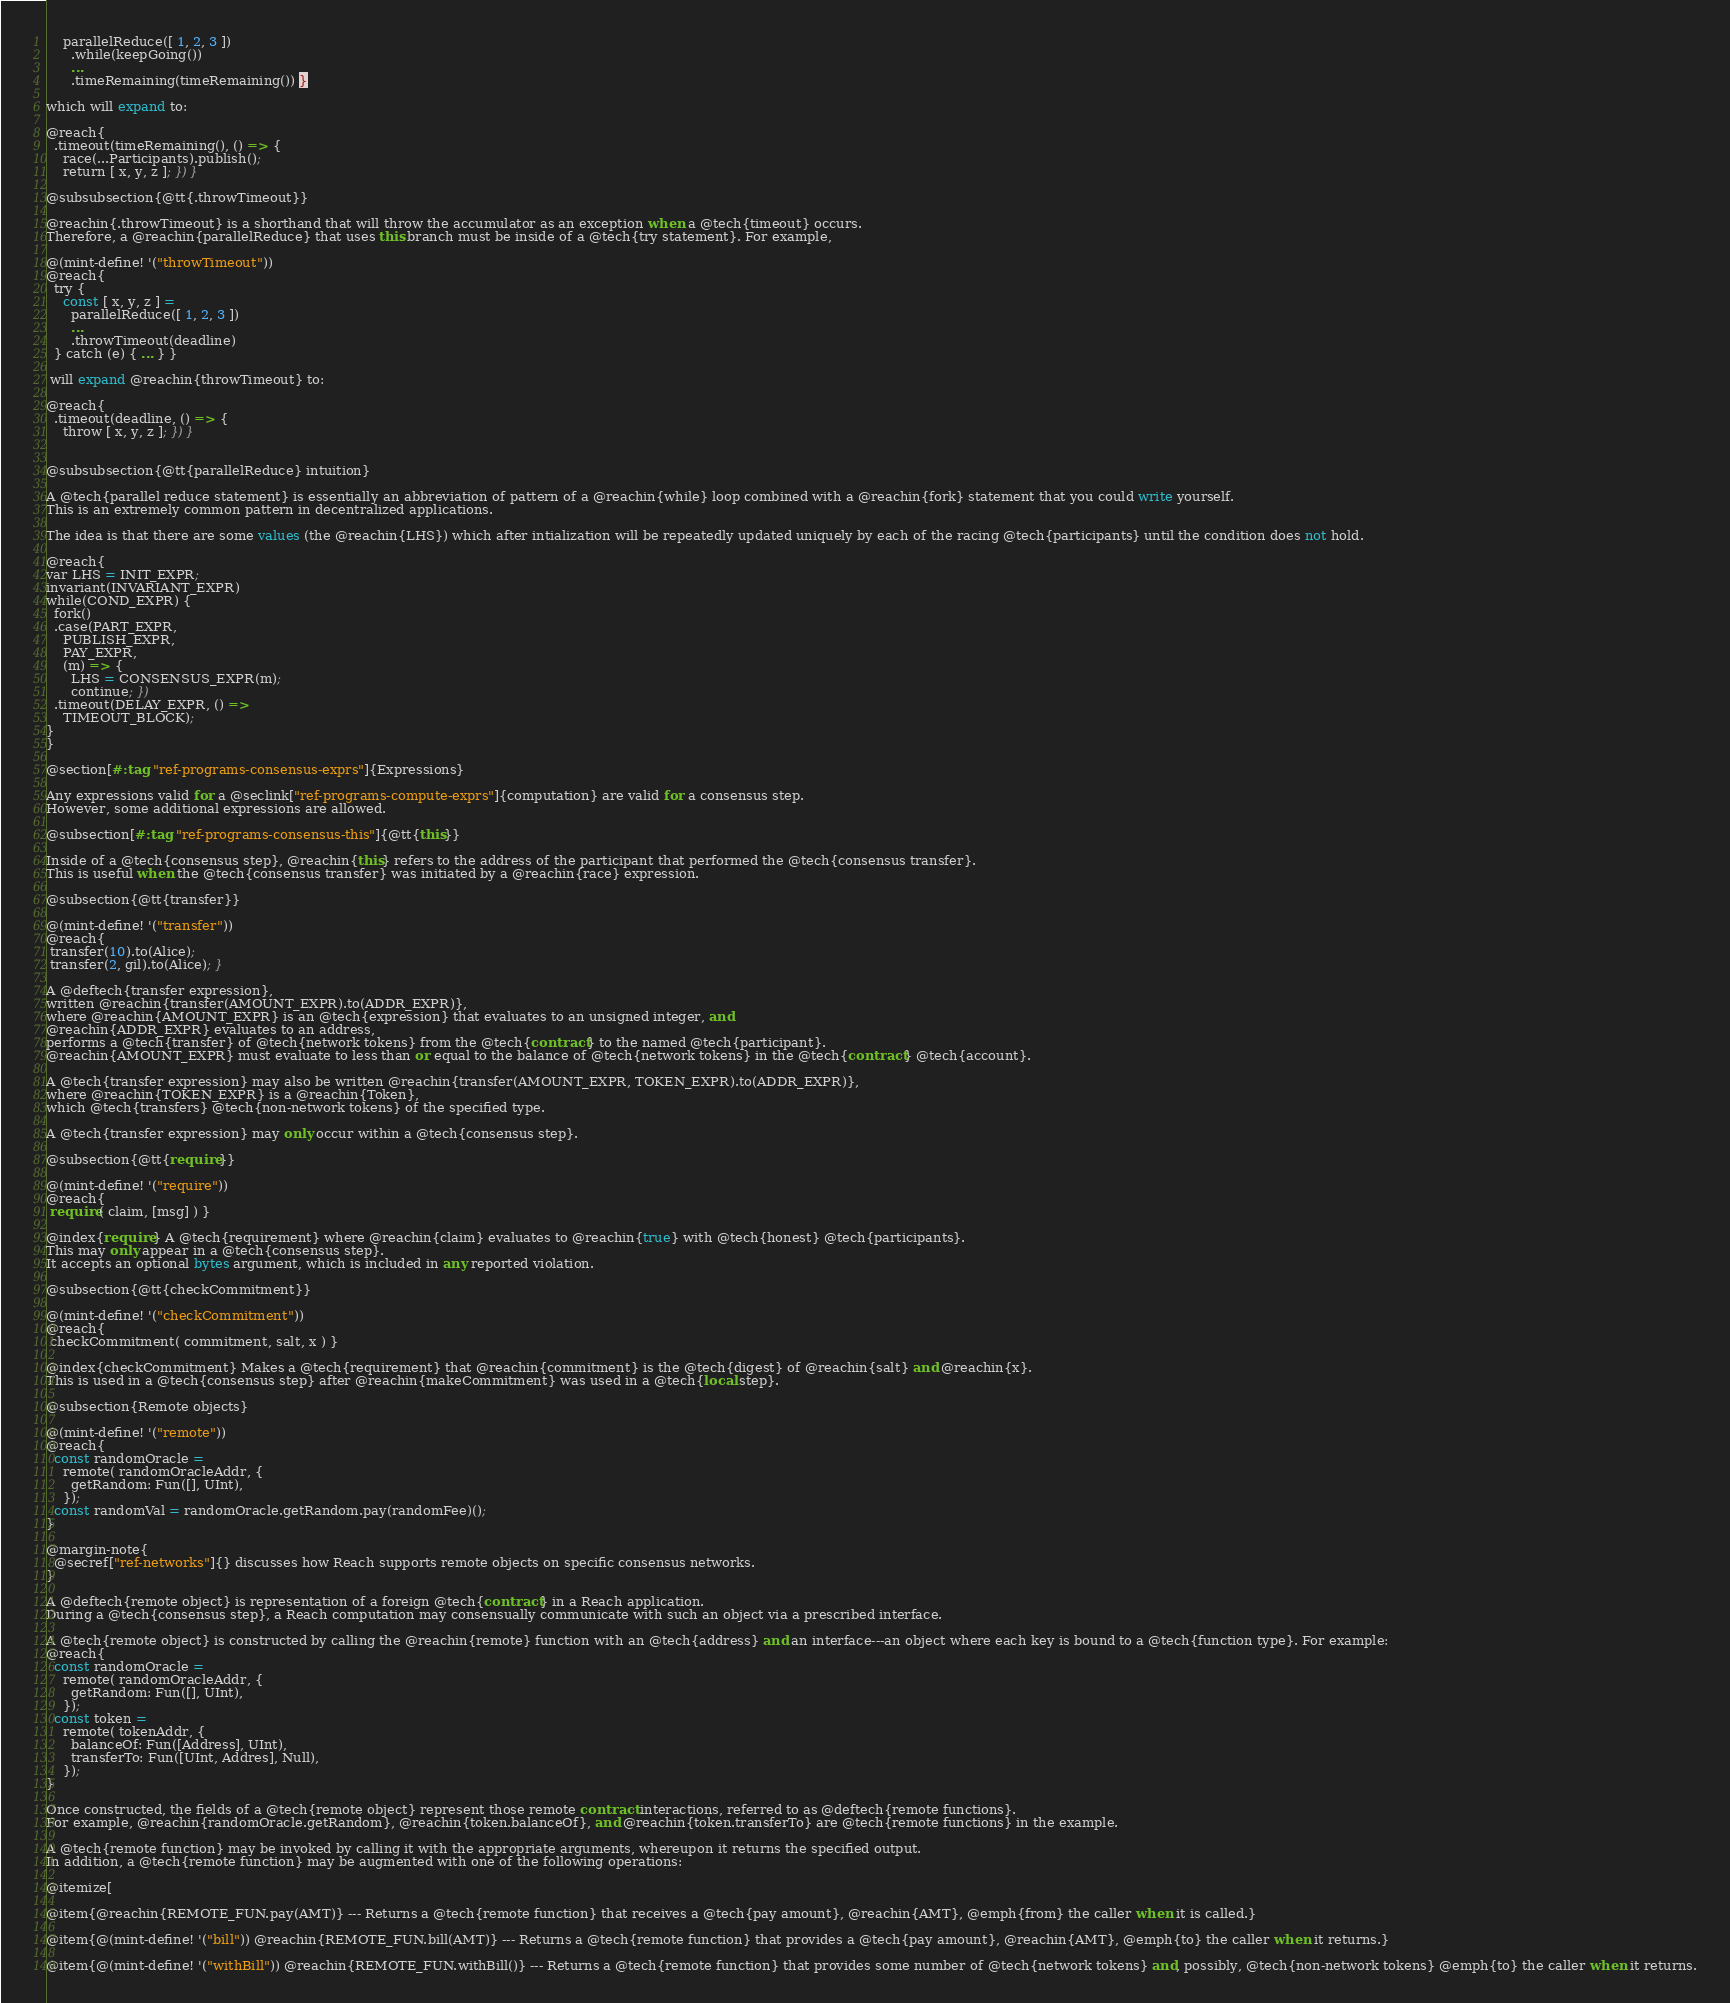<code> <loc_0><loc_0><loc_500><loc_500><_Racket_>    parallelReduce([ 1, 2, 3 ])
      .while(keepGoing())
      ...
      .timeRemaining(timeRemaining()) }

which will expand to:

@reach{
  .timeout(timeRemaining(), () => {
    race(...Participants).publish();
    return [ x, y, z ]; }) }

@subsubsection{@tt{.throwTimeout}}

@reachin{.throwTimeout} is a shorthand that will throw the accumulator as an exception when a @tech{timeout} occurs.
Therefore, a @reachin{parallelReduce} that uses this branch must be inside of a @tech{try statement}. For example,

@(mint-define! '("throwTimeout"))
@reach{
  try {
    const [ x, y, z ] =
      parallelReduce([ 1, 2, 3 ])
      ...
      .throwTimeout(deadline)
  } catch (e) { ... } }

 will expand @reachin{throwTimeout} to:

@reach{
  .timeout(deadline, () => {
    throw [ x, y, z ]; }) }


@subsubsection{@tt{parallelReduce} intuition}

A @tech{parallel reduce statement} is essentially an abbreviation of pattern of a @reachin{while} loop combined with a @reachin{fork} statement that you could write yourself.
This is an extremely common pattern in decentralized applications.

The idea is that there are some values (the @reachin{LHS}) which after intialization will be repeatedly updated uniquely by each of the racing @tech{participants} until the condition does not hold.

@reach{
var LHS = INIT_EXPR;
invariant(INVARIANT_EXPR)
while(COND_EXPR) {
  fork()
  .case(PART_EXPR,
    PUBLISH_EXPR,
    PAY_EXPR,
    (m) => {
      LHS = CONSENSUS_EXPR(m);
      continue; })
  .timeout(DELAY_EXPR, () =>
    TIMEOUT_BLOCK);
}
}

@section[#:tag "ref-programs-consensus-exprs"]{Expressions}

Any expressions valid for a @seclink["ref-programs-compute-exprs"]{computation} are valid for a consensus step.
However, some additional expressions are allowed.

@subsection[#:tag "ref-programs-consensus-this"]{@tt{this}}

Inside of a @tech{consensus step}, @reachin{this} refers to the address of the participant that performed the @tech{consensus transfer}.
This is useful when the @tech{consensus transfer} was initiated by a @reachin{race} expression.

@subsection{@tt{transfer}}

@(mint-define! '("transfer"))
@reach{
 transfer(10).to(Alice);
 transfer(2, gil).to(Alice); }

A @deftech{transfer expression},
written @reachin{transfer(AMOUNT_EXPR).to(ADDR_EXPR)},
where @reachin{AMOUNT_EXPR} is an @tech{expression} that evaluates to an unsigned integer, and
@reachin{ADDR_EXPR} evaluates to an address,
performs a @tech{transfer} of @tech{network tokens} from the @tech{contract} to the named @tech{participant}.
@reachin{AMOUNT_EXPR} must evaluate to less than or equal to the balance of @tech{network tokens} in the @tech{contract} @tech{account}.

A @tech{transfer expression} may also be written @reachin{transfer(AMOUNT_EXPR, TOKEN_EXPR).to(ADDR_EXPR)},
where @reachin{TOKEN_EXPR} is a @reachin{Token},
which @tech{transfers} @tech{non-network tokens} of the specified type.

A @tech{transfer expression} may only occur within a @tech{consensus step}.

@subsection{@tt{require}}

@(mint-define! '("require"))
@reach{
 require( claim, [msg] ) }

@index{require} A @tech{requirement} where @reachin{claim} evaluates to @reachin{true} with @tech{honest} @tech{participants}.
This may only appear in a @tech{consensus step}.
It accepts an optional bytes argument, which is included in any reported violation.

@subsection{@tt{checkCommitment}}

@(mint-define! '("checkCommitment"))
@reach{
 checkCommitment( commitment, salt, x ) }

@index{checkCommitment} Makes a @tech{requirement} that @reachin{commitment} is the @tech{digest} of @reachin{salt} and @reachin{x}.
This is used in a @tech{consensus step} after @reachin{makeCommitment} was used in a @tech{local step}.

@subsection{Remote objects}

@(mint-define! '("remote"))
@reach{
  const randomOracle =
    remote( randomOracleAddr, {
      getRandom: Fun([], UInt),
    });
  const randomVal = randomOracle.getRandom.pay(randomFee)();
}

@margin-note{
  @secref["ref-networks"]{} discusses how Reach supports remote objects on specific consensus networks.
}

A @deftech{remote object} is representation of a foreign @tech{contract} in a Reach application.
During a @tech{consensus step}, a Reach computation may consensually communicate with such an object via a prescribed interface.

A @tech{remote object} is constructed by calling the @reachin{remote} function with an @tech{address} and an interface---an object where each key is bound to a @tech{function type}. For example:
@reach{
  const randomOracle =
    remote( randomOracleAddr, {
      getRandom: Fun([], UInt),
    });
  const token =
    remote( tokenAddr, {
      balanceOf: Fun([Address], UInt),
      transferTo: Fun([UInt, Addres], Null),
    });
}

Once constructed, the fields of a @tech{remote object} represent those remote contract interactions, referred to as @deftech{remote functions}.
For example, @reachin{randomOracle.getRandom}, @reachin{token.balanceOf}, and @reachin{token.transferTo} are @tech{remote functions} in the example.

A @tech{remote function} may be invoked by calling it with the appropriate arguments, whereupon it returns the specified output.
In addition, a @tech{remote function} may be augmented with one of the following operations:

@itemize[

@item{@reachin{REMOTE_FUN.pay(AMT)} --- Returns a @tech{remote function} that receives a @tech{pay amount}, @reachin{AMT}, @emph{from} the caller when it is called.}

@item{@(mint-define! '("bill")) @reachin{REMOTE_FUN.bill(AMT)} --- Returns a @tech{remote function} that provides a @tech{pay amount}, @reachin{AMT}, @emph{to} the caller when it returns.}

@item{@(mint-define! '("withBill")) @reachin{REMOTE_FUN.withBill()} --- Returns a @tech{remote function} that provides some number of @tech{network tokens} and, possibly, @tech{non-network tokens} @emph{to} the caller when it returns.</code> 